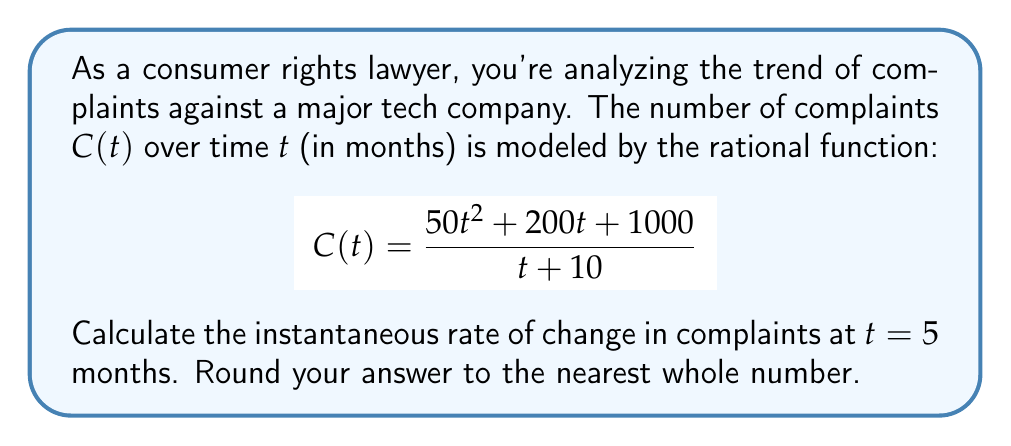Help me with this question. To find the instantaneous rate of change at $t = 5$, we need to calculate the derivative of $C(t)$ and evaluate it at $t = 5$. Let's follow these steps:

1) First, let's find $C'(t)$ using the quotient rule:
   $$C'(t) = \frac{(t+10)(100t+200) - (50t^2+200t+1000)(1)}{(t+10)^2}$$

2) Simplify the numerator:
   $$C'(t) = \frac{100t^2 + 1000t + 200t + 2000 - 50t^2 - 200t - 1000}{(t+10)^2}$$
   $$C'(t) = \frac{50t^2 + 1000t + 1000}{(t+10)^2}$$

3) Now, evaluate $C'(5)$:
   $$C'(5) = \frac{50(5)^2 + 1000(5) + 1000}{(5+10)^2}$$
   $$C'(5) = \frac{1250 + 5000 + 1000}{225}$$
   $$C'(5) = \frac{7250}{225}$$

4) Calculate and round to the nearest whole number:
   $$C'(5) \approx 32.22 \approx 32$$

Therefore, the instantaneous rate of change in complaints at $t = 5$ months is approximately 32 complaints per month.
Answer: 32 complaints/month 